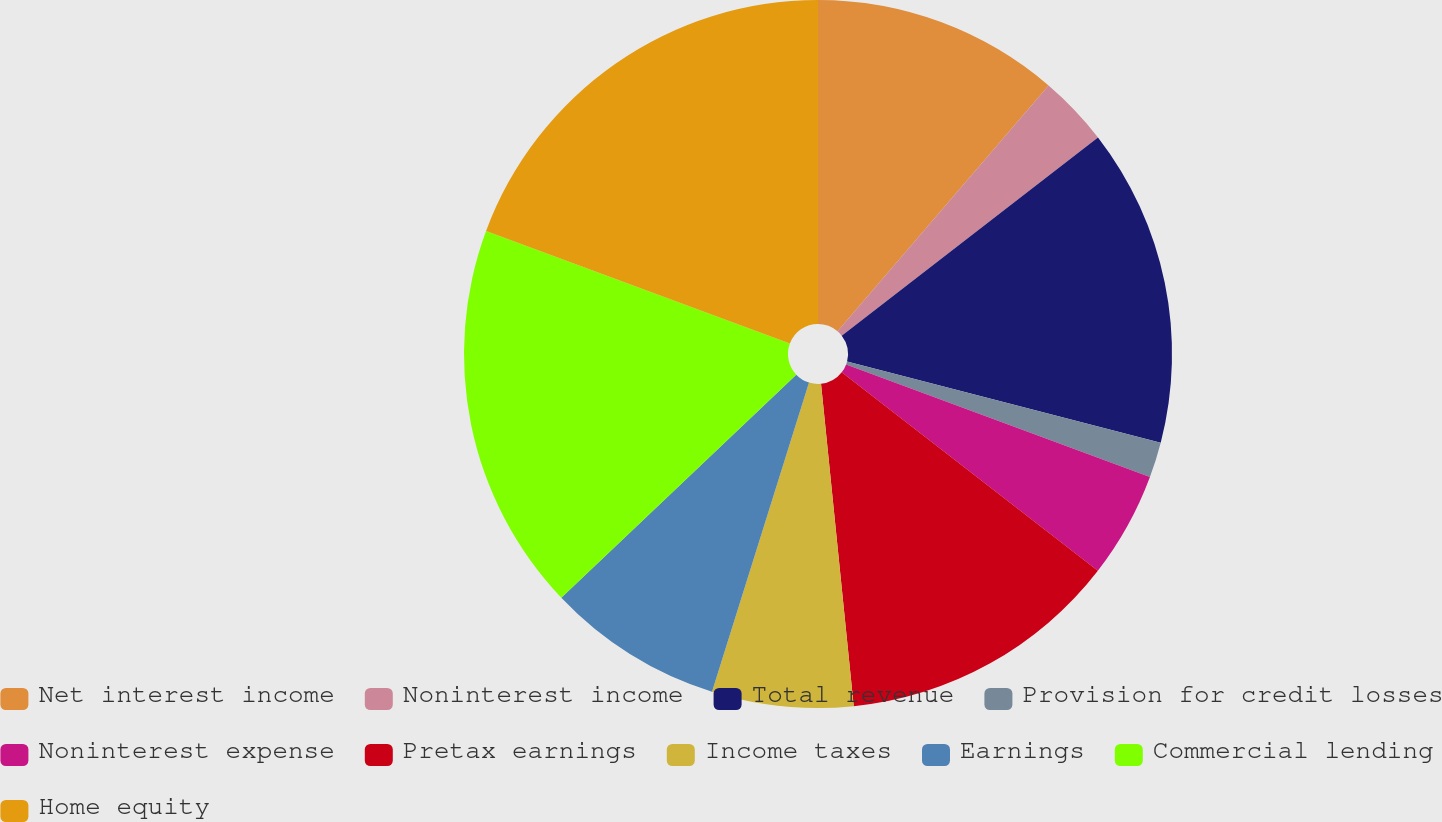Convert chart. <chart><loc_0><loc_0><loc_500><loc_500><pie_chart><fcel>Net interest income<fcel>Noninterest income<fcel>Total revenue<fcel>Provision for credit losses<fcel>Noninterest expense<fcel>Pretax earnings<fcel>Income taxes<fcel>Earnings<fcel>Commercial lending<fcel>Home equity<nl><fcel>11.29%<fcel>3.23%<fcel>14.51%<fcel>1.62%<fcel>4.84%<fcel>12.9%<fcel>6.45%<fcel>8.07%<fcel>17.74%<fcel>19.35%<nl></chart> 